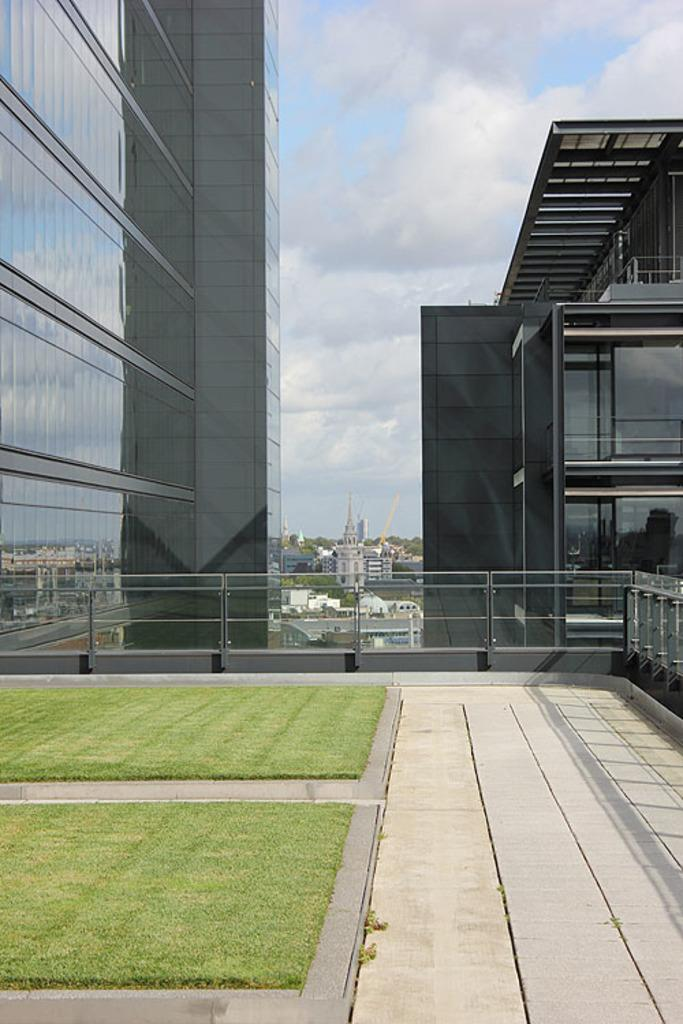What type of surface is on the left side of the image? There is grass on the surface on the left side of the image. What type of fence is present in the image? There is a metal fence in the image. What can be seen in the background of the image? There are buildings, trees, and the sky visible in the background of the image. How many ducks are present on the farm in the image? There is no farm or ducks present in the image. What type of tool is being used to dig in the grass? There is no tool or digging activity visible in the image. 